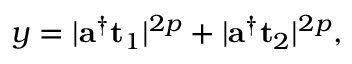<formula> <loc_0><loc_0><loc_500><loc_500>y = | a ^ { \dag } t _ { 1 } | ^ { 2 p } + | a ^ { \dag } t _ { 2 } | ^ { 2 p } ,</formula> 